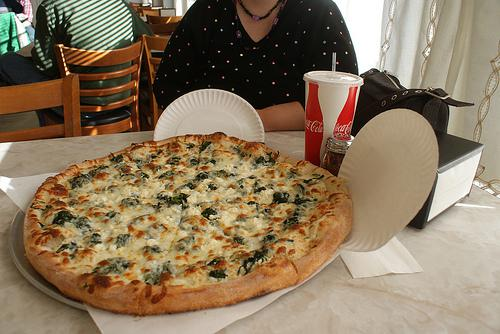Question: what brand is on the cup?
Choices:
A. Coca Cola.
B. McDonalds.
C. Pepsi.
D. A&w.
Answer with the letter. Answer: A Question: how many people are there?
Choices:
A. One.
B. Eight.
C. Twelve.
D. Two.
Answer with the letter. Answer: D Question: what color are the plates?
Choices:
A. White.
B. Grey.
C. Yellow.
D. Blue.
Answer with the letter. Answer: A Question: what are the plates made of?
Choices:
A. Ceramic.
B. Paper.
C. Plastic.
D. Wood.
Answer with the letter. Answer: B Question: what is on the plate?
Choices:
A. Salad.
B. Dessert.
C. Hamburgers.
D. Pizza.
Answer with the letter. Answer: D Question: what is on the pizza?
Choices:
A. Cheese.
B. Mushrooms.
C. Spinach.
D. Pepperoni.
Answer with the letter. Answer: C 